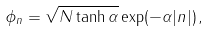Convert formula to latex. <formula><loc_0><loc_0><loc_500><loc_500>\phi _ { n } = \sqrt { N \tanh \alpha } \exp ( - \alpha | n | ) \, ,</formula> 